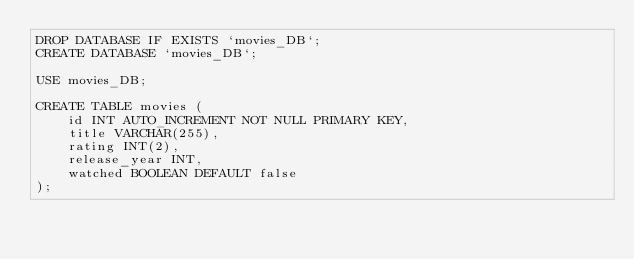<code> <loc_0><loc_0><loc_500><loc_500><_SQL_>DROP DATABASE IF EXISTS `movies_DB`;
CREATE DATABASE `movies_DB`;

USE movies_DB;

CREATE TABLE movies (
    id INT AUTO_INCREMENT NOT NULL PRIMARY KEY,
    title VARCHAR(255),
    rating INT(2), 
    release_year INT,
    watched BOOLEAN DEFAULT false
);</code> 